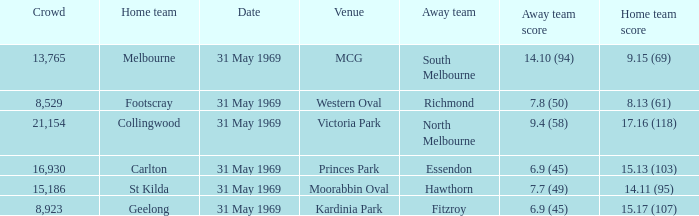In the event where the home team registered 1 Fitzroy. 